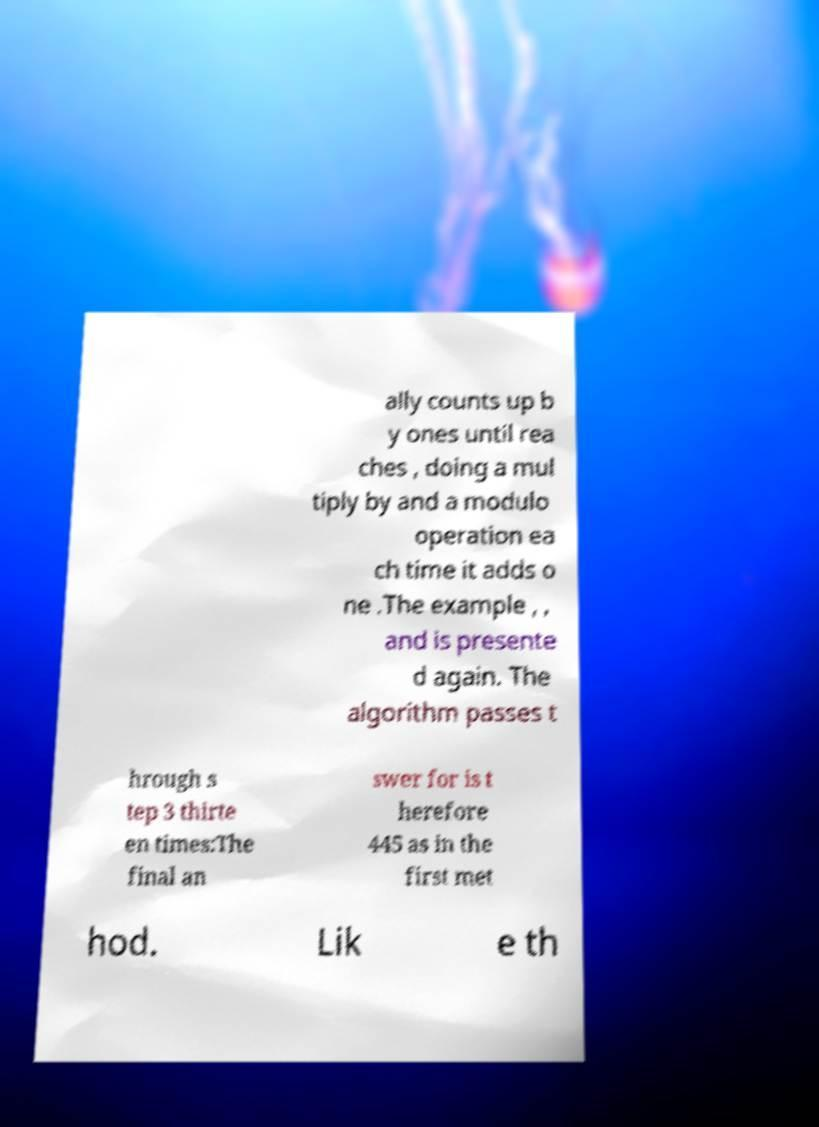There's text embedded in this image that I need extracted. Can you transcribe it verbatim? ally counts up b y ones until rea ches , doing a mul tiply by and a modulo operation ea ch time it adds o ne .The example , , and is presente d again. The algorithm passes t hrough s tep 3 thirte en times:The final an swer for is t herefore 445 as in the first met hod. Lik e th 